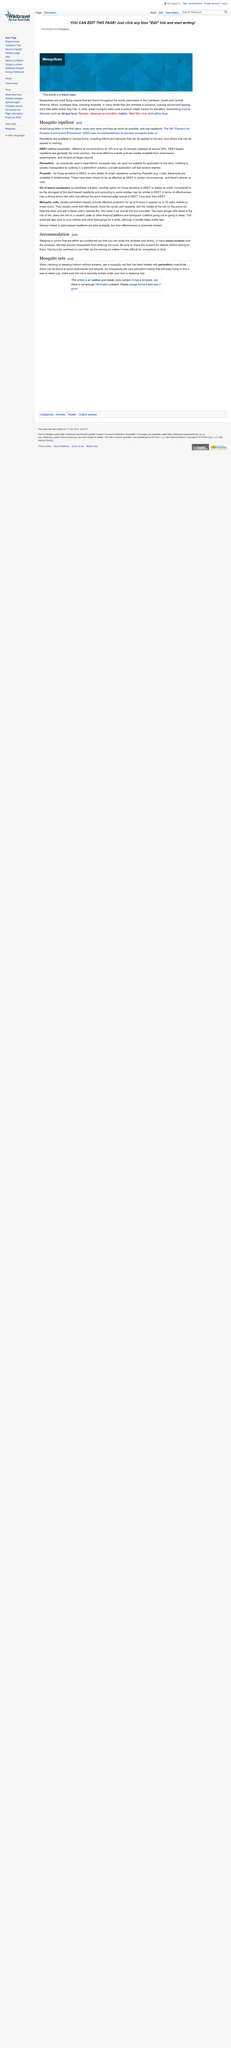Point out several critical features in this image. Mosquito coils are generally considered safe to use, but there is a risk of fire. Therefore, it is important to place the coil on a ceramic plate or other fireproof platform and extinguish it before going out or going to sleep to minimize the risk of fire. DEET-sensitive individuals should use oil of lemon eucalyptus and picaridin mosquito repellents instead. The Centers for Disease Control and Prevention recommend several mosquito repellents, including DEET, permethrin, picaridin, oil of lemon eucalyptus, and mosquito coils, to help protect against mosquito bites. 